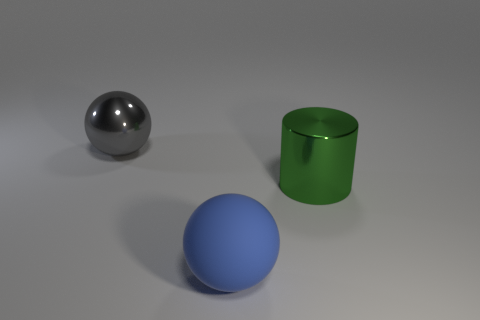The metallic thing that is behind the metallic thing that is in front of the ball behind the blue ball is what shape?
Your answer should be very brief. Sphere. Are there the same number of big blue rubber balls that are behind the metallic cylinder and purple rubber spheres?
Your answer should be compact. Yes. Do the gray shiny ball and the blue ball have the same size?
Give a very brief answer. Yes. How many rubber objects are either green cylinders or tiny red cubes?
Your answer should be very brief. 0. There is a gray sphere that is the same size as the green metallic thing; what material is it?
Offer a very short reply. Metal. What number of other things are there of the same material as the blue sphere
Make the answer very short. 0. Are there fewer blue things behind the metallic ball than big matte balls?
Keep it short and to the point. Yes. Is the shape of the big blue thing the same as the large gray metal thing?
Give a very brief answer. Yes. There is a thing that is to the left of the ball that is in front of the large gray thing behind the blue object; how big is it?
Your answer should be very brief. Large. There is another thing that is the same shape as the big gray metallic object; what material is it?
Offer a very short reply. Rubber. 